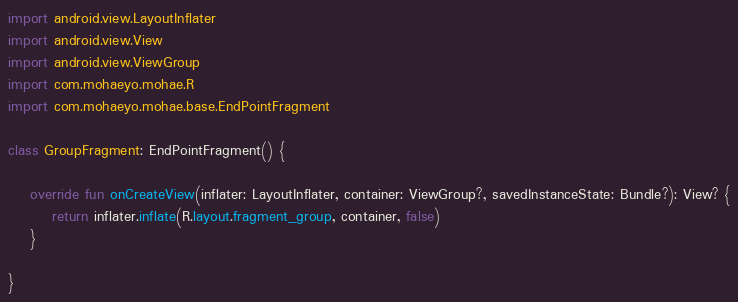<code> <loc_0><loc_0><loc_500><loc_500><_Kotlin_>import android.view.LayoutInflater
import android.view.View
import android.view.ViewGroup
import com.mohaeyo.mohae.R
import com.mohaeyo.mohae.base.EndPointFragment

class GroupFragment: EndPointFragment() {

    override fun onCreateView(inflater: LayoutInflater, container: ViewGroup?, savedInstanceState: Bundle?): View? {
        return inflater.inflate(R.layout.fragment_group, container, false)
    }

}</code> 